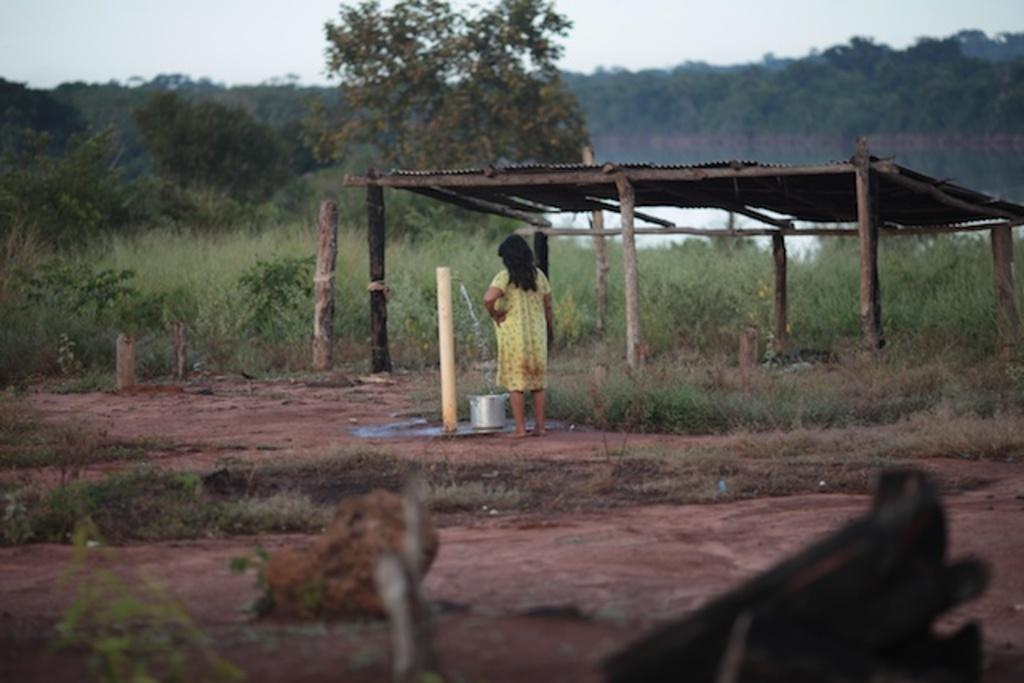What is the main subject in the image? There is a person standing in the image. What object can be seen near the person? There is a tap in the image. What is the liquid substance visible in the image? There is water in the image. What is placed on the ground in the image? There is a bowl on the ground in the image. What type of structure is present in the image? There is a shed in the image. What type of vegetation is visible in the image? There are plants and trees in the image. What is visible in the background of the image? The sky is visible in the background of the image. How many geese are sitting on the bottle in the image? There is no bottle or geese present in the image. What advice does the person's grandmother give in the image? There is no mention of a grandmother or any advice in the image. 